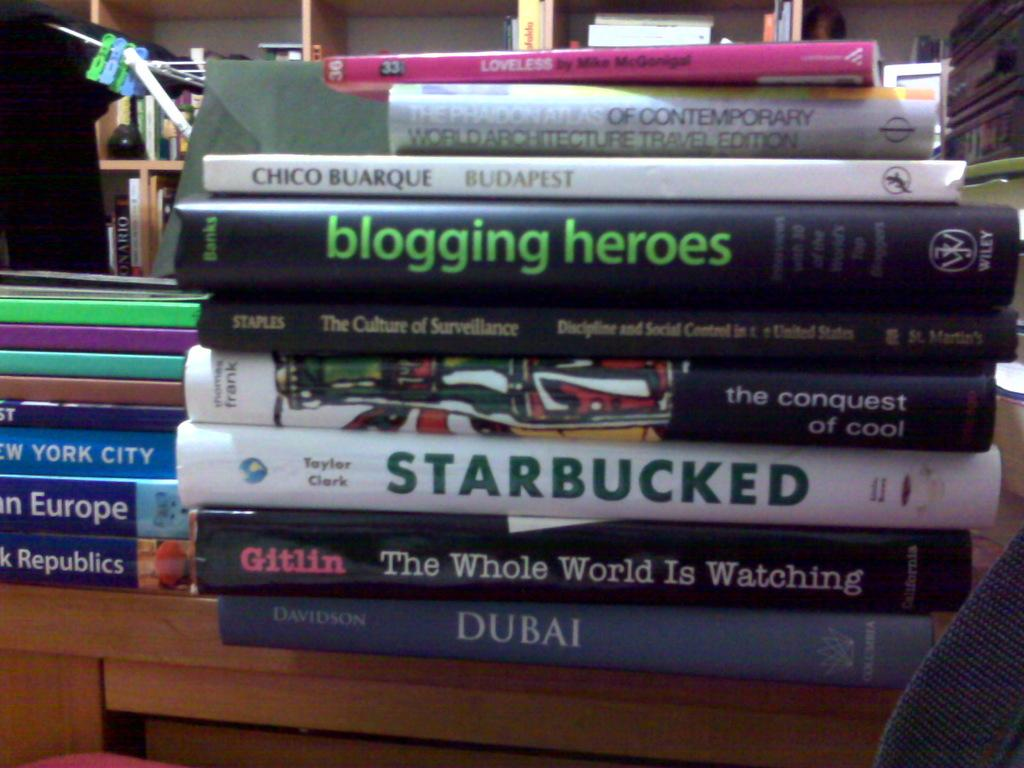<image>
Create a compact narrative representing the image presented. the words blogging heroes is on the black book 